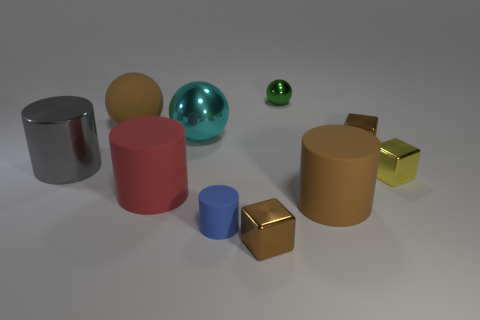Subtract all blue cylinders. How many brown blocks are left? 2 Subtract all big gray metal cylinders. How many cylinders are left? 3 Subtract 2 cylinders. How many cylinders are left? 2 Subtract all red cylinders. How many cylinders are left? 3 Subtract all balls. How many objects are left? 7 Add 5 small objects. How many small objects exist? 10 Subtract 1 yellow blocks. How many objects are left? 9 Subtract all yellow cylinders. Subtract all gray spheres. How many cylinders are left? 4 Subtract all brown matte things. Subtract all big cyan metallic spheres. How many objects are left? 7 Add 8 big spheres. How many big spheres are left? 10 